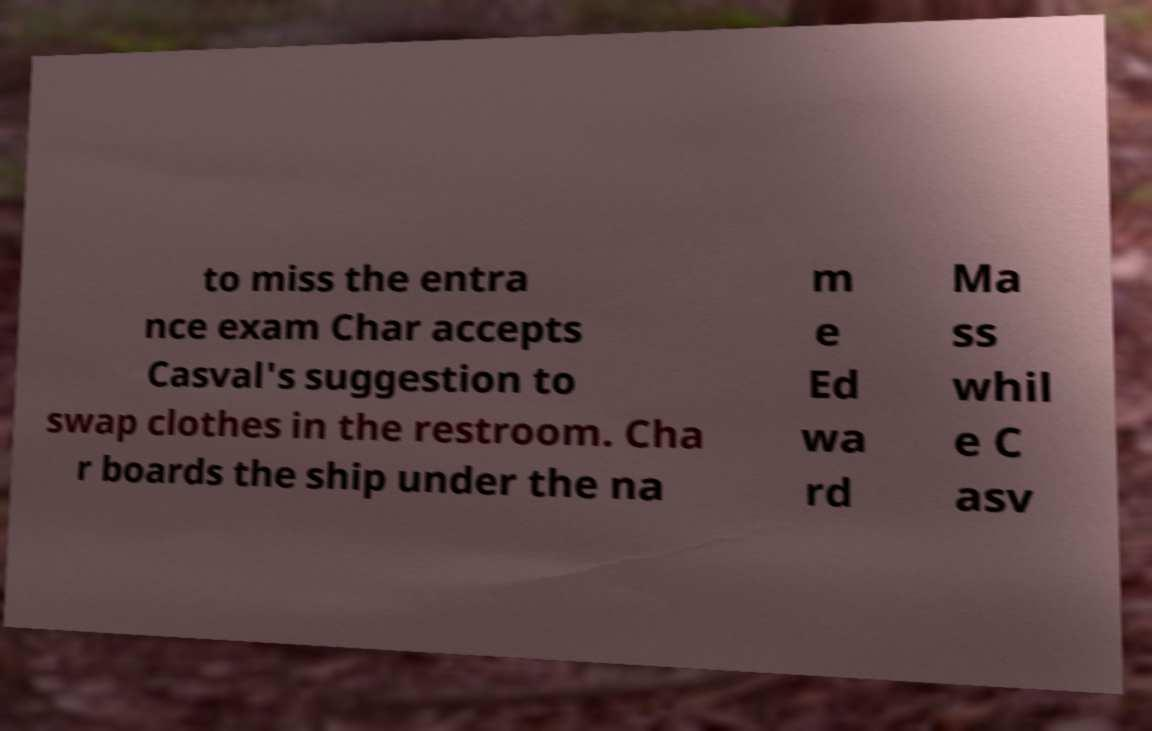I need the written content from this picture converted into text. Can you do that? to miss the entra nce exam Char accepts Casval's suggestion to swap clothes in the restroom. Cha r boards the ship under the na m e Ed wa rd Ma ss whil e C asv 